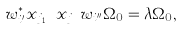<formula> <loc_0><loc_0><loc_500><loc_500>w _ { i ^ { \prime } } ^ { * } x _ { j _ { 1 } } \cdots x _ { j _ { m } } w _ { i ^ { \prime \prime } } \Omega _ { 0 } = \lambda \Omega _ { 0 } ,</formula> 